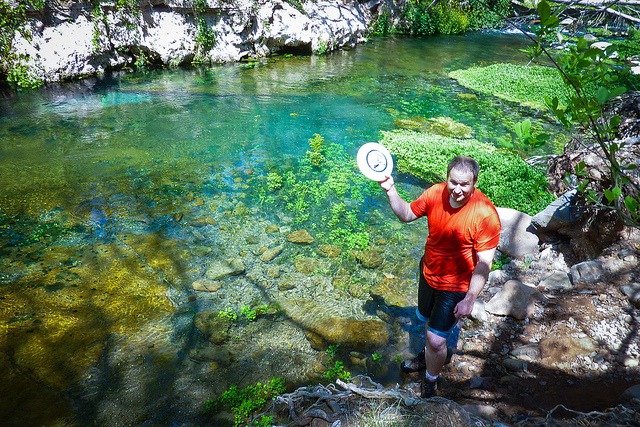What type of environment is depicted in the photograph? The image showcases a pristine natural environment, featuring a clear stream with visible rocks beneath the surface, surrounded by lush greenery indicative of a forest or woodland area.  Are there any specific animal or plant species you can identify? Without a closer inspection to provide a detailed analysis, it's challenging to accurately identify specific species of animals or plants. However, the environment appears to be conducive to freshwater fish, amphibians, and various plant species typical of a forested waterway ecosystem. 